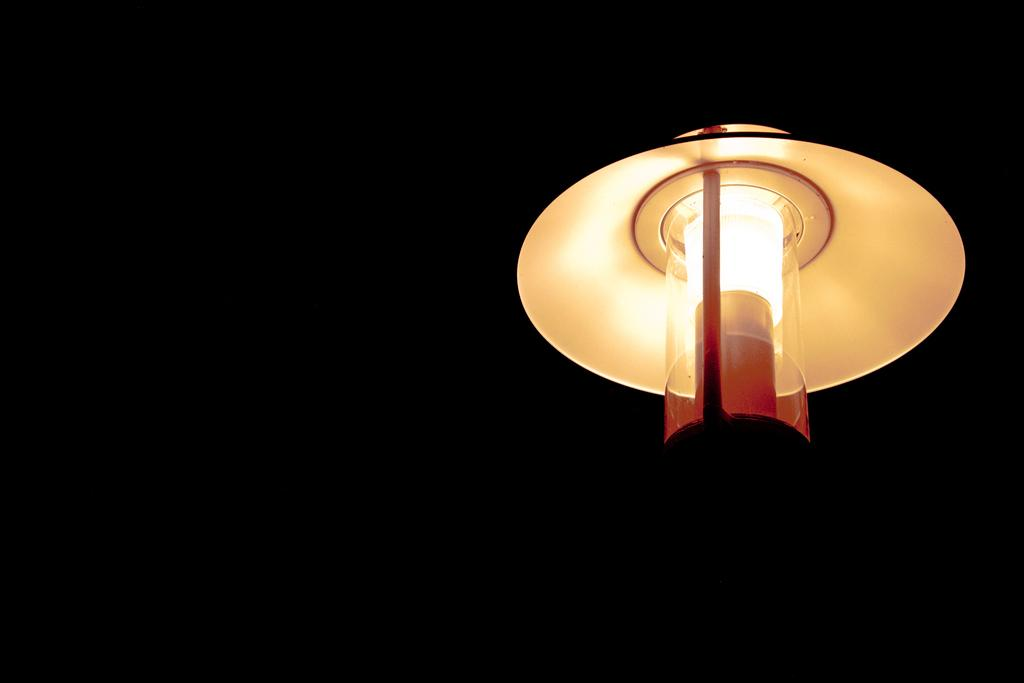What object is the main focus of the image? There is a light lamp in the image. What color is the background of the image? The background of the image is black. How much money does the porter receive for carrying the light lamp in the image? There is no porter or indication of payment in the image; it only features a light lamp with a black background. 